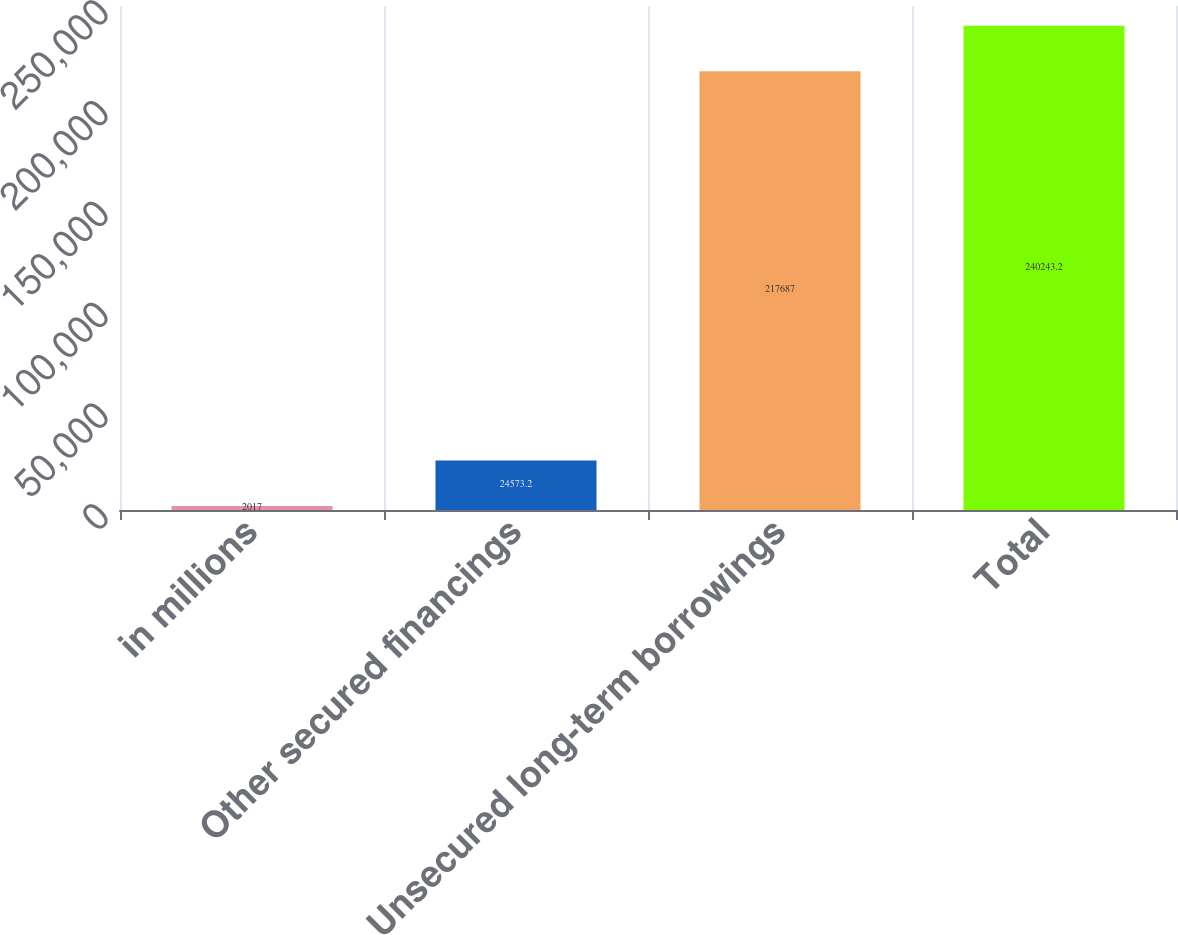<chart> <loc_0><loc_0><loc_500><loc_500><bar_chart><fcel>in millions<fcel>Other secured financings<fcel>Unsecured long-term borrowings<fcel>Total<nl><fcel>2017<fcel>24573.2<fcel>217687<fcel>240243<nl></chart> 